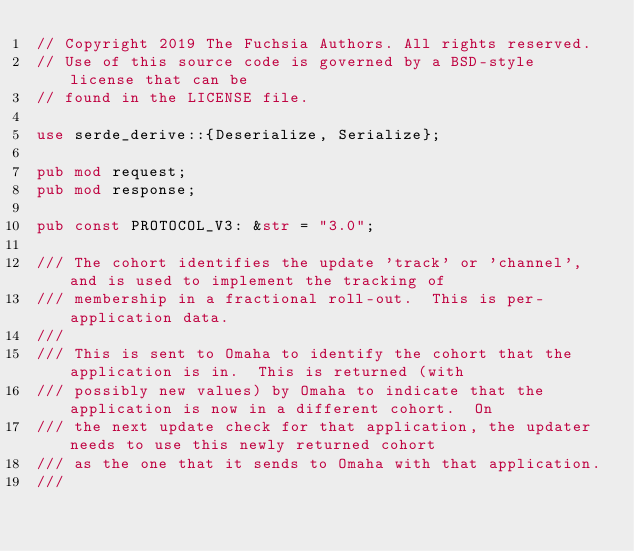Convert code to text. <code><loc_0><loc_0><loc_500><loc_500><_Rust_>// Copyright 2019 The Fuchsia Authors. All rights reserved.
// Use of this source code is governed by a BSD-style license that can be
// found in the LICENSE file.

use serde_derive::{Deserialize, Serialize};

pub mod request;
pub mod response;

pub const PROTOCOL_V3: &str = "3.0";

/// The cohort identifies the update 'track' or 'channel', and is used to implement the tracking of
/// membership in a fractional roll-out.  This is per-application data.
///
/// This is sent to Omaha to identify the cohort that the application is in.  This is returned (with
/// possibly new values) by Omaha to indicate that the application is now in a different cohort.  On
/// the next update check for that application, the updater needs to use this newly returned cohort
/// as the one that it sends to Omaha with that application.
///</code> 